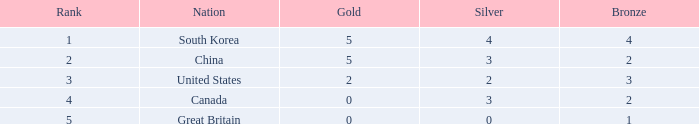I'm looking to parse the entire table for insights. Could you assist me with that? {'header': ['Rank', 'Nation', 'Gold', 'Silver', 'Bronze'], 'rows': [['1', 'South Korea', '5', '4', '4'], ['2', 'China', '5', '3', '2'], ['3', 'United States', '2', '2', '3'], ['4', 'Canada', '0', '3', '2'], ['5', 'Great Britain', '0', '0', '1']]} What is the lowest Gold, when Nation is Canada, and when Rank is greater than 4? None. 